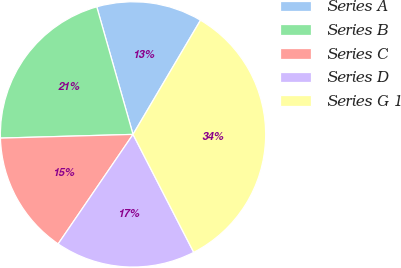Convert chart. <chart><loc_0><loc_0><loc_500><loc_500><pie_chart><fcel>Series A<fcel>Series B<fcel>Series C<fcel>Series D<fcel>Series G 1<nl><fcel>12.9%<fcel>21.04%<fcel>15.01%<fcel>17.11%<fcel>33.94%<nl></chart> 